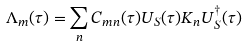Convert formula to latex. <formula><loc_0><loc_0><loc_500><loc_500>\Lambda _ { m } ( \tau ) = \sum _ { n } C _ { m n } ( \tau ) U _ { S } ( \tau ) K _ { n } U _ { S } ^ { \dagger } ( \tau )</formula> 